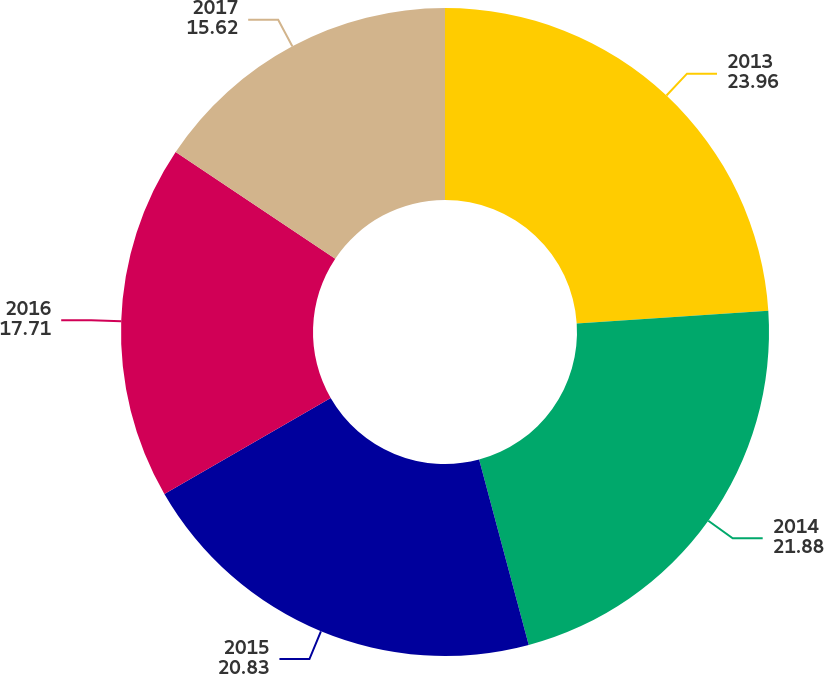Convert chart to OTSL. <chart><loc_0><loc_0><loc_500><loc_500><pie_chart><fcel>2013<fcel>2014<fcel>2015<fcel>2016<fcel>2017<nl><fcel>23.96%<fcel>21.88%<fcel>20.83%<fcel>17.71%<fcel>15.62%<nl></chart> 